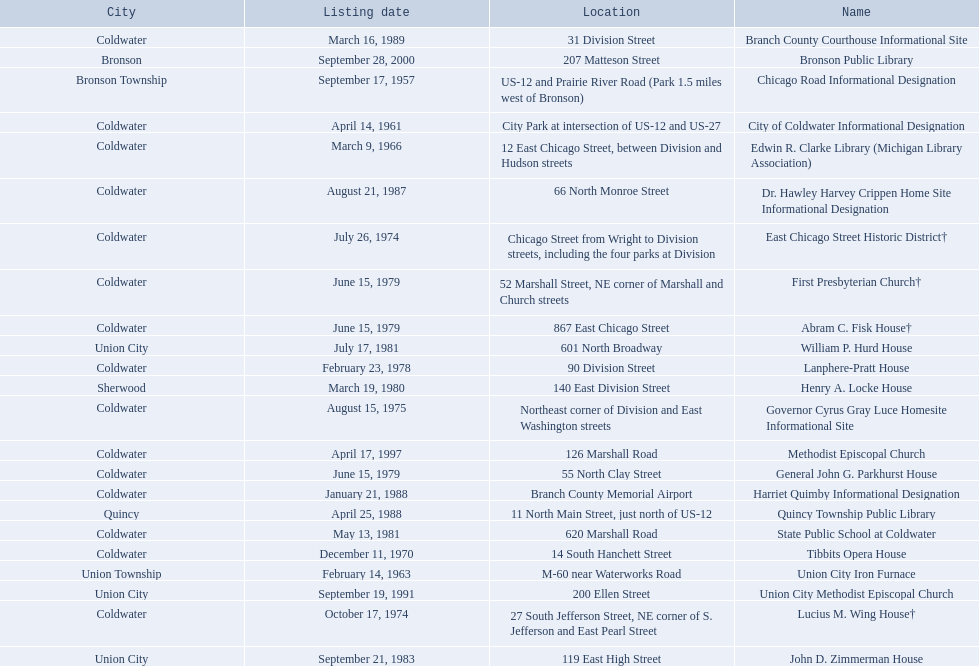I'm looking to parse the entire table for insights. Could you assist me with that? {'header': ['City', 'Listing date', 'Location', 'Name'], 'rows': [['Coldwater', 'March 16, 1989', '31 Division Street', 'Branch County Courthouse Informational Site'], ['Bronson', 'September 28, 2000', '207 Matteson Street', 'Bronson Public Library'], ['Bronson Township', 'September 17, 1957', 'US-12 and Prairie River Road (Park 1.5 miles west of Bronson)', 'Chicago Road Informational Designation'], ['Coldwater', 'April 14, 1961', 'City Park at intersection of US-12 and US-27', 'City of Coldwater Informational Designation'], ['Coldwater', 'March 9, 1966', '12 East Chicago Street, between Division and Hudson streets', 'Edwin R. Clarke Library (Michigan Library Association)'], ['Coldwater', 'August 21, 1987', '66 North Monroe Street', 'Dr. Hawley Harvey Crippen Home Site Informational Designation'], ['Coldwater', 'July 26, 1974', 'Chicago Street from Wright to Division streets, including the four parks at Division', 'East Chicago Street Historic District†'], ['Coldwater', 'June 15, 1979', '52 Marshall Street, NE corner of Marshall and Church streets', 'First Presbyterian Church†'], ['Coldwater', 'June 15, 1979', '867 East Chicago Street', 'Abram C. Fisk House†'], ['Union City', 'July 17, 1981', '601 North Broadway', 'William P. Hurd House'], ['Coldwater', 'February 23, 1978', '90 Division Street', 'Lanphere-Pratt House'], ['Sherwood', 'March 19, 1980', '140 East Division Street', 'Henry A. Locke House'], ['Coldwater', 'August 15, 1975', 'Northeast corner of Division and East Washington streets', 'Governor Cyrus Gray Luce Homesite Informational Site'], ['Coldwater', 'April 17, 1997', '126 Marshall Road', 'Methodist Episcopal Church'], ['Coldwater', 'June 15, 1979', '55 North Clay Street', 'General John G. Parkhurst House'], ['Coldwater', 'January 21, 1988', 'Branch County Memorial Airport', 'Harriet Quimby Informational Designation'], ['Quincy', 'April 25, 1988', '11 North Main Street, just north of US-12', 'Quincy Township Public Library'], ['Coldwater', 'May 13, 1981', '620 Marshall Road', 'State Public School at Coldwater'], ['Coldwater', 'December 11, 1970', '14 South Hanchett Street', 'Tibbits Opera House'], ['Union Township', 'February 14, 1963', 'M-60 near Waterworks Road', 'Union City Iron Furnace'], ['Union City', 'September 19, 1991', '200 Ellen Street', 'Union City Methodist Episcopal Church'], ['Coldwater', 'October 17, 1974', '27 South Jefferson Street, NE corner of S. Jefferson and East Pearl Street', 'Lucius M. Wing House†'], ['Union City', 'September 21, 1983', '119 East High Street', 'John D. Zimmerman House']]} In branch co. mi what historic sites are located on a near a highway? Chicago Road Informational Designation, City of Coldwater Informational Designation, Quincy Township Public Library, Union City Iron Furnace. Of the historic sites ins branch co. near highways, which ones are near only us highways? Chicago Road Informational Designation, City of Coldwater Informational Designation, Quincy Township Public Library. Which historical sites in branch co. are near only us highways and are not a building? Chicago Road Informational Designation, City of Coldwater Informational Designation. Which non-building historical sites in branch county near a us highways is closest to bronson? Chicago Road Informational Designation. 